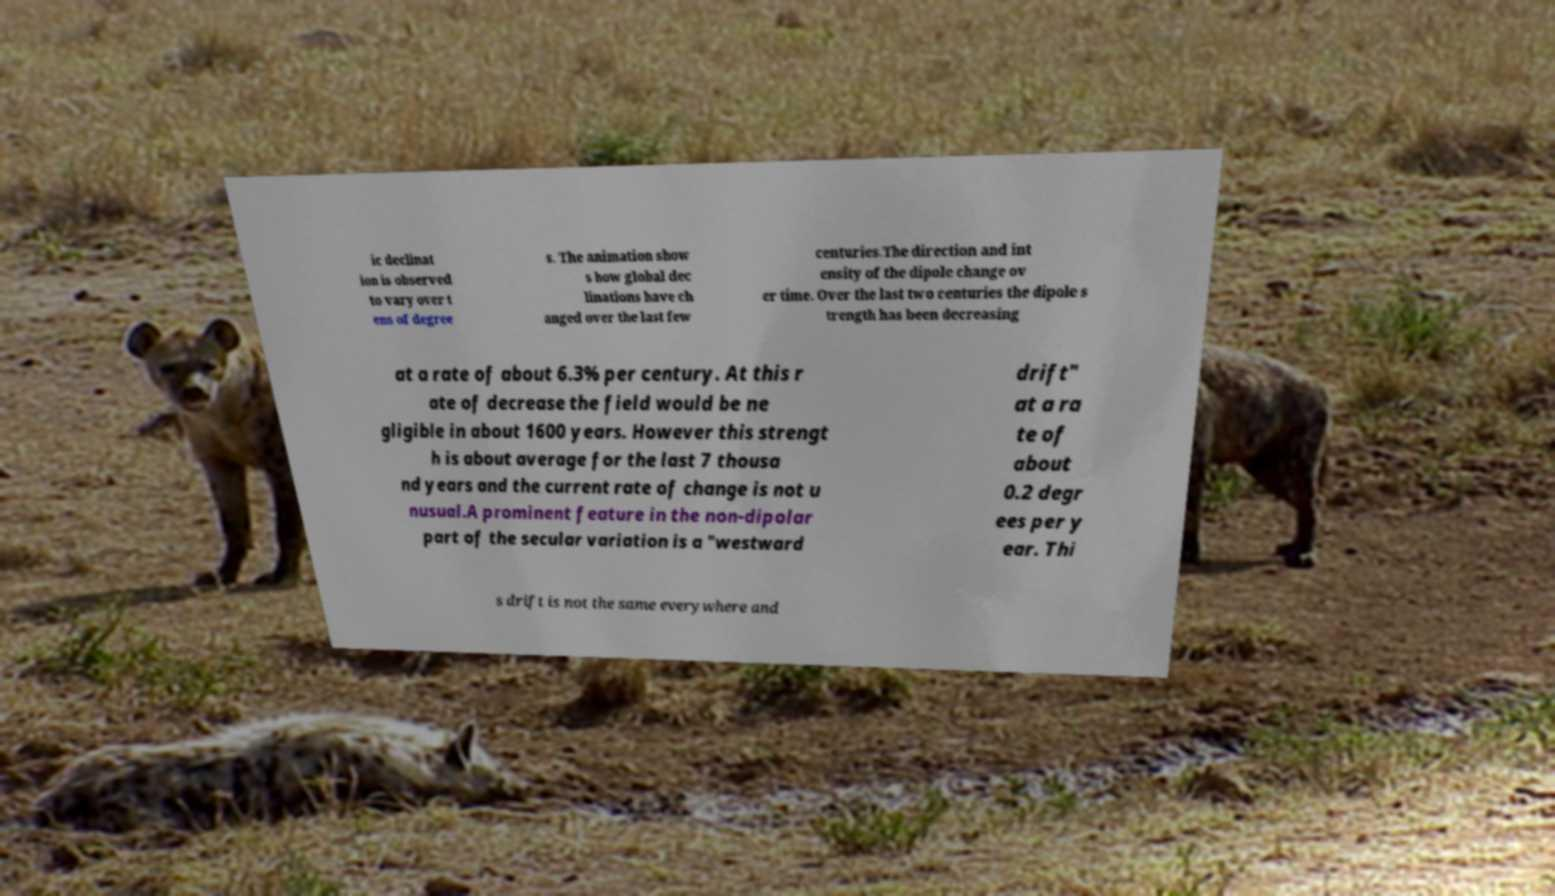For documentation purposes, I need the text within this image transcribed. Could you provide that? ic declinat ion is observed to vary over t ens of degree s. The animation show s how global dec linations have ch anged over the last few centuries.The direction and int ensity of the dipole change ov er time. Over the last two centuries the dipole s trength has been decreasing at a rate of about 6.3% per century. At this r ate of decrease the field would be ne gligible in about 1600 years. However this strengt h is about average for the last 7 thousa nd years and the current rate of change is not u nusual.A prominent feature in the non-dipolar part of the secular variation is a "westward drift" at a ra te of about 0.2 degr ees per y ear. Thi s drift is not the same everywhere and 